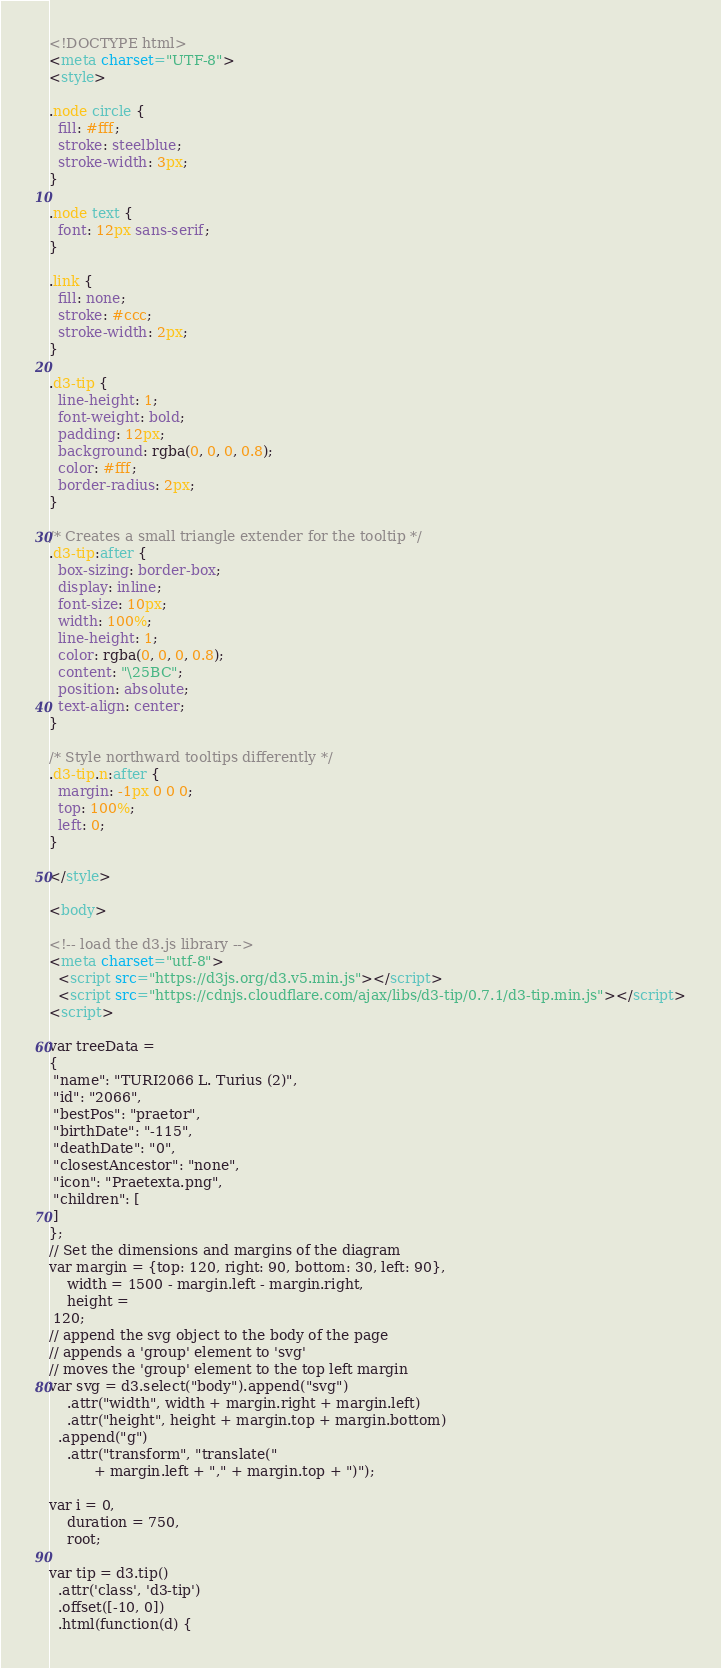Convert code to text. <code><loc_0><loc_0><loc_500><loc_500><_HTML_><!DOCTYPE html>
<meta charset="UTF-8">
<style>

.node circle {
  fill: #fff;
  stroke: steelblue;
  stroke-width: 3px;
}

.node text {
  font: 12px sans-serif;
}

.link {
  fill: none;
  stroke: #ccc;
  stroke-width: 2px;
}

.d3-tip {
  line-height: 1;
  font-weight: bold;
  padding: 12px;
  background: rgba(0, 0, 0, 0.8);
  color: #fff;
  border-radius: 2px;
}

/* Creates a small triangle extender for the tooltip */
.d3-tip:after {
  box-sizing: border-box;
  display: inline;
  font-size: 10px;
  width: 100%;
  line-height: 1;
  color: rgba(0, 0, 0, 0.8);
  content: "\25BC";
  position: absolute;
  text-align: center;
}

/* Style northward tooltips differently */
.d3-tip.n:after {
  margin: -1px 0 0 0;
  top: 100%;
  left: 0;
}

</style>

<body>

<!-- load the d3.js library -->	
<meta charset="utf-8">
  <script src="https://d3js.org/d3.v5.min.js"></script>
  <script src="https://cdnjs.cloudflare.com/ajax/libs/d3-tip/0.7.1/d3-tip.min.js"></script>
<script>

var treeData =
{
 "name": "TURI2066 L. Turius (2)",
 "id": "2066",
 "bestPos": "praetor",
 "birthDate": "-115",
 "deathDate": "0",
 "closestAncestor": "none",
 "icon": "Praetexta.png",
 "children": [
 ]
};
// Set the dimensions and margins of the diagram
var margin = {top: 120, right: 90, bottom: 30, left: 90},
    width = 1500 - margin.left - margin.right,
    height = 
 120;
// append the svg object to the body of the page
// appends a 'group' element to 'svg'
// moves the 'group' element to the top left margin
var svg = d3.select("body").append("svg")
    .attr("width", width + margin.right + margin.left)
    .attr("height", height + margin.top + margin.bottom)
  .append("g")
    .attr("transform", "translate("
          + margin.left + "," + margin.top + ")");

var i = 0,
    duration = 750,
    root;

var tip = d3.tip()
  .attr('class', 'd3-tip')
  .offset([-10, 0])
  .html(function(d) {</code> 